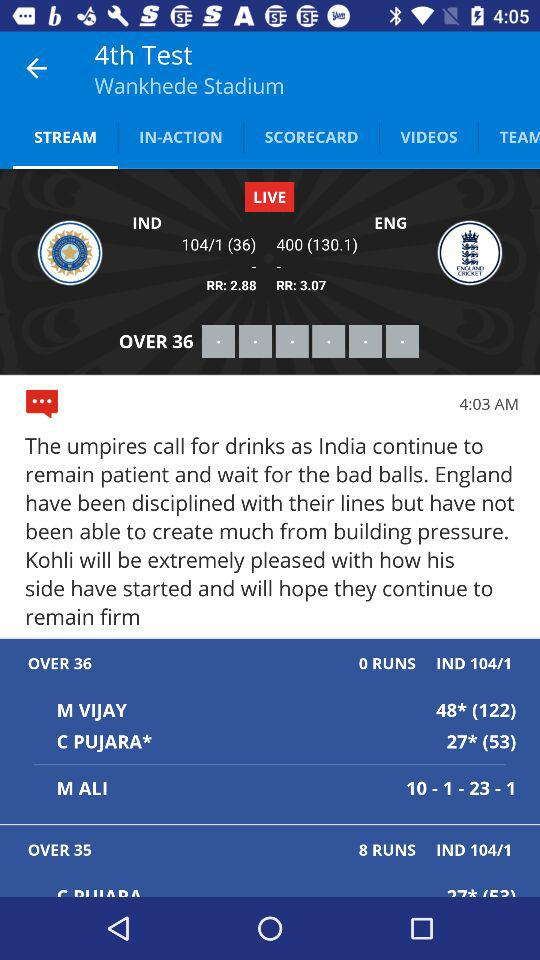How many runs does M Vijay have? M Vijay has 48 runs. 